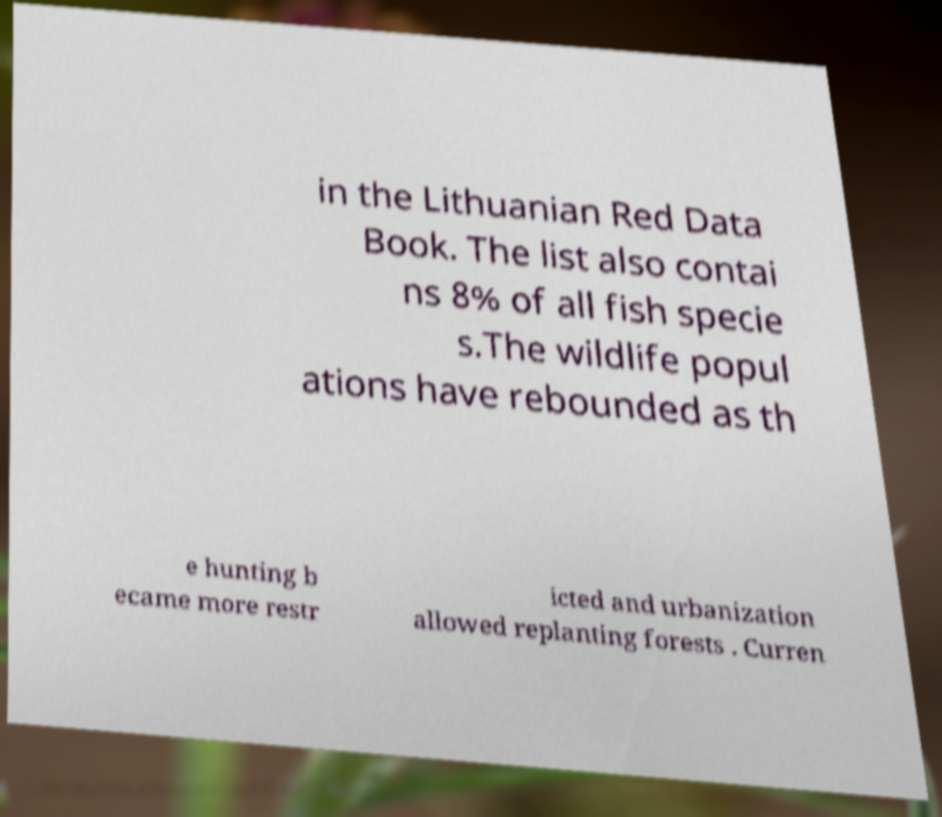Could you extract and type out the text from this image? in the Lithuanian Red Data Book. The list also contai ns 8% of all fish specie s.The wildlife popul ations have rebounded as th e hunting b ecame more restr icted and urbanization allowed replanting forests . Curren 